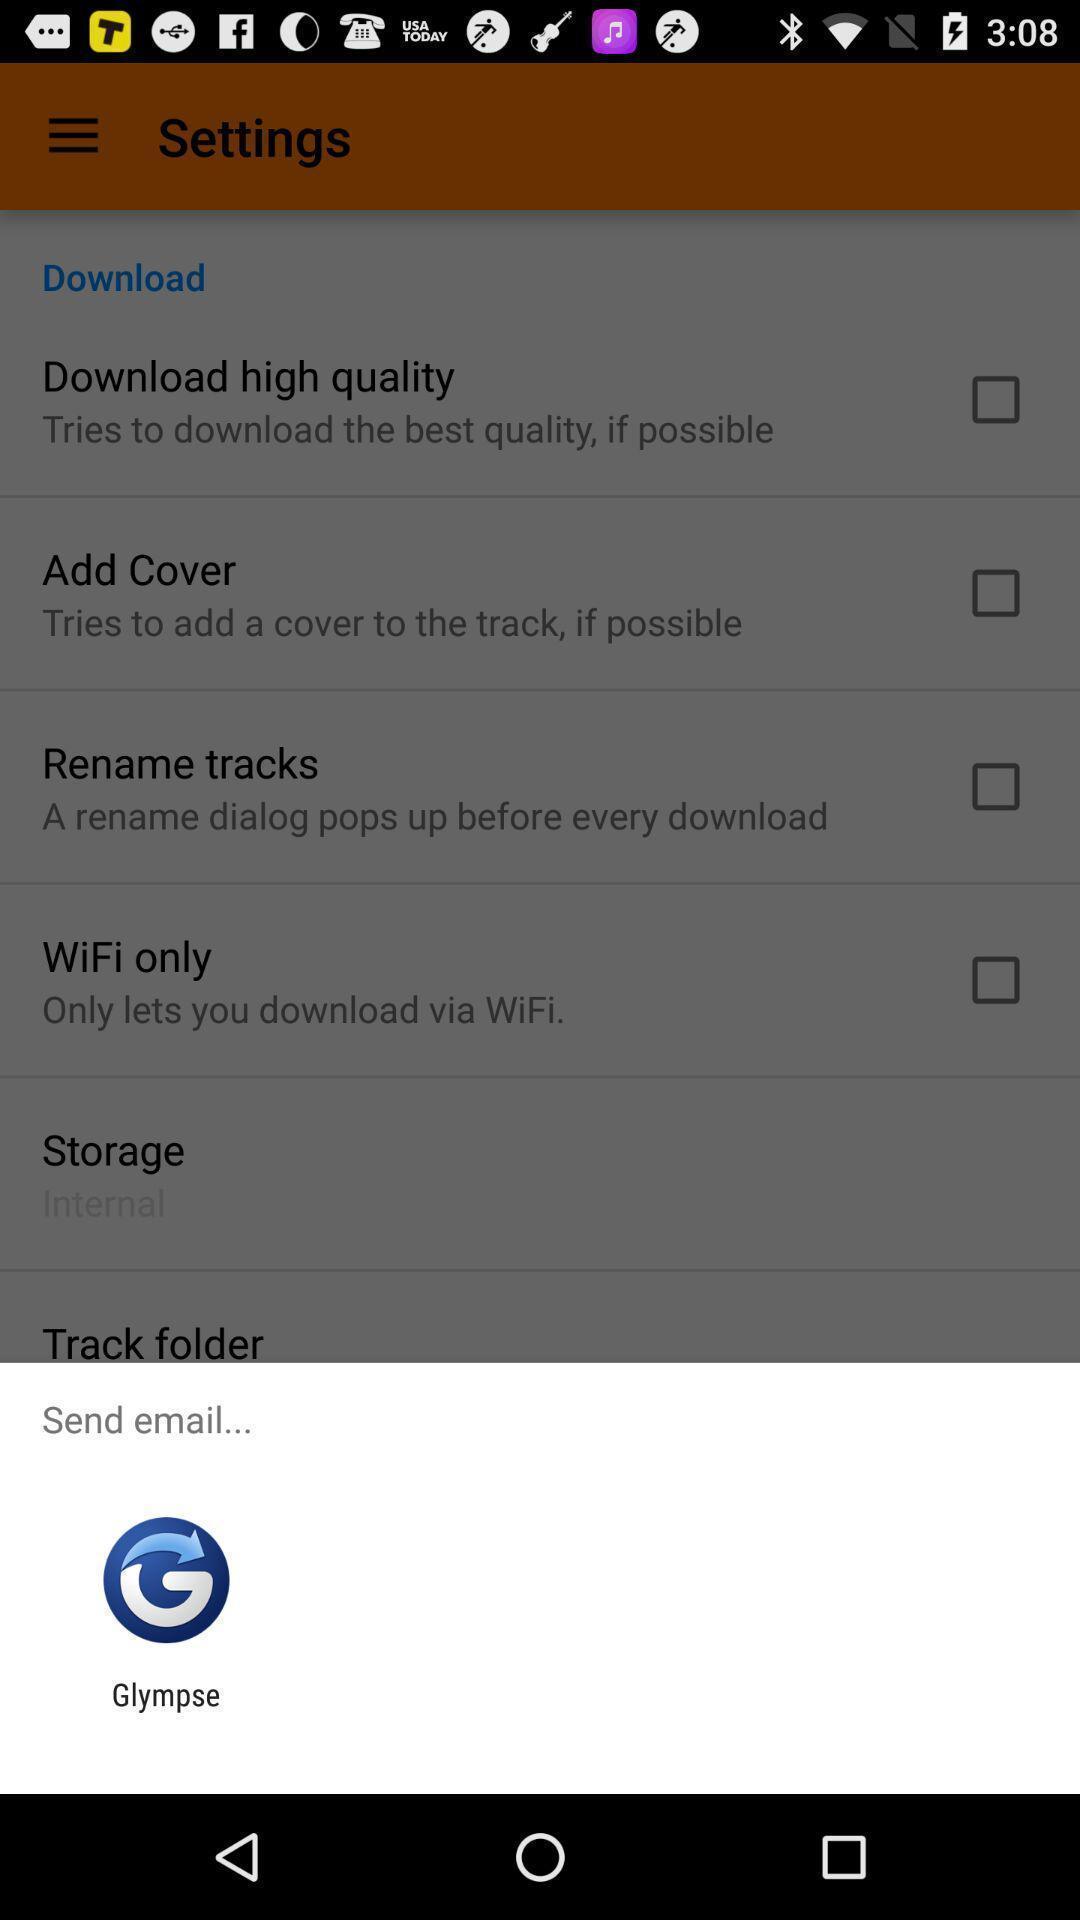Provide a detailed account of this screenshot. Push up message for sending mail via social network. 